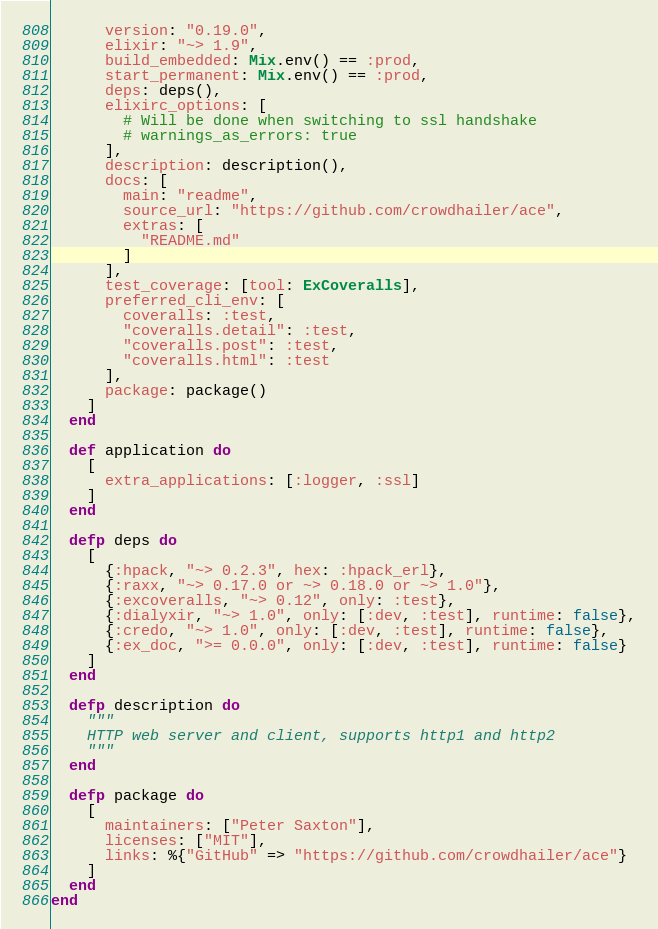<code> <loc_0><loc_0><loc_500><loc_500><_Elixir_>      version: "0.19.0",
      elixir: "~> 1.9",
      build_embedded: Mix.env() == :prod,
      start_permanent: Mix.env() == :prod,
      deps: deps(),
      elixirc_options: [
        # Will be done when switching to ssl handshake
        # warnings_as_errors: true
      ],
      description: description(),
      docs: [
        main: "readme",
        source_url: "https://github.com/crowdhailer/ace",
        extras: [
          "README.md"
        ]
      ],
      test_coverage: [tool: ExCoveralls],
      preferred_cli_env: [
        coveralls: :test,
        "coveralls.detail": :test,
        "coveralls.post": :test,
        "coveralls.html": :test
      ],
      package: package()
    ]
  end

  def application do
    [
      extra_applications: [:logger, :ssl]
    ]
  end

  defp deps do
    [
      {:hpack, "~> 0.2.3", hex: :hpack_erl},
      {:raxx, "~> 0.17.0 or ~> 0.18.0 or ~> 1.0"},
      {:excoveralls, "~> 0.12", only: :test},
      {:dialyxir, "~> 1.0", only: [:dev, :test], runtime: false},
      {:credo, "~> 1.0", only: [:dev, :test], runtime: false},
      {:ex_doc, ">= 0.0.0", only: [:dev, :test], runtime: false}
    ]
  end

  defp description do
    """
    HTTP web server and client, supports http1 and http2
    """
  end

  defp package do
    [
      maintainers: ["Peter Saxton"],
      licenses: ["MIT"],
      links: %{"GitHub" => "https://github.com/crowdhailer/ace"}
    ]
  end
end
</code> 